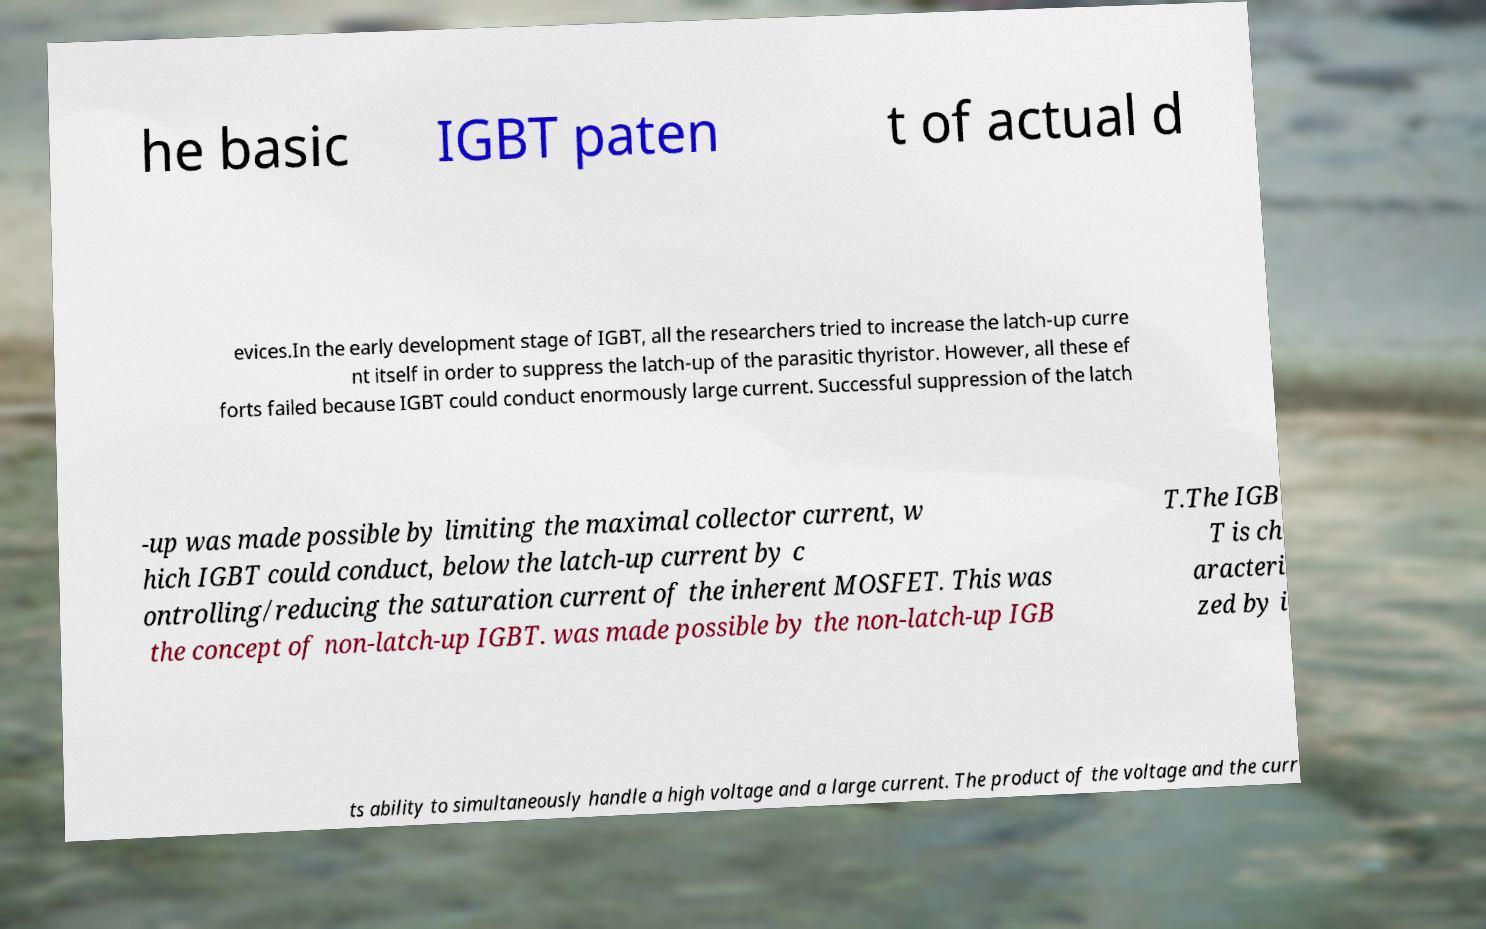Could you extract and type out the text from this image? he basic IGBT paten t of actual d evices.In the early development stage of IGBT, all the researchers tried to increase the latch-up curre nt itself in order to suppress the latch-up of the parasitic thyristor. However, all these ef forts failed because IGBT could conduct enormously large current. Successful suppression of the latch -up was made possible by limiting the maximal collector current, w hich IGBT could conduct, below the latch-up current by c ontrolling/reducing the saturation current of the inherent MOSFET. This was the concept of non-latch-up IGBT. was made possible by the non-latch-up IGB T.The IGB T is ch aracteri zed by i ts ability to simultaneously handle a high voltage and a large current. The product of the voltage and the curr 